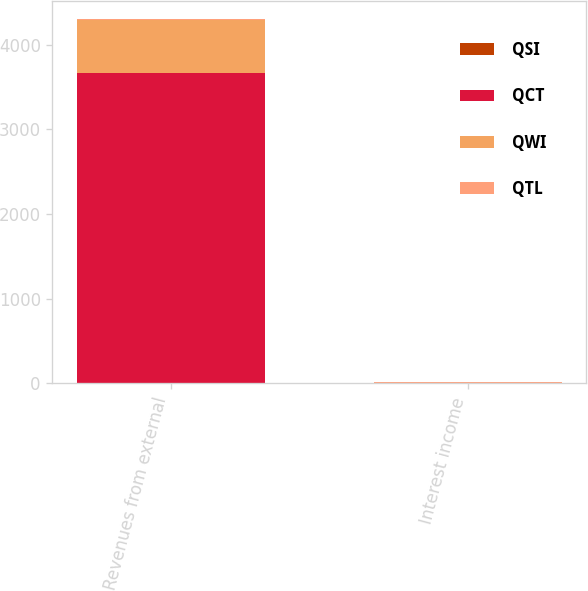Convert chart to OTSL. <chart><loc_0><loc_0><loc_500><loc_500><stacked_bar_chart><ecel><fcel>Revenues from external<fcel>Interest income<nl><fcel>QSI<fcel>8<fcel>1<nl><fcel>QCT<fcel>3659<fcel>2<nl><fcel>QWI<fcel>628<fcel>2<nl><fcel>QTL<fcel>9<fcel>8<nl></chart> 